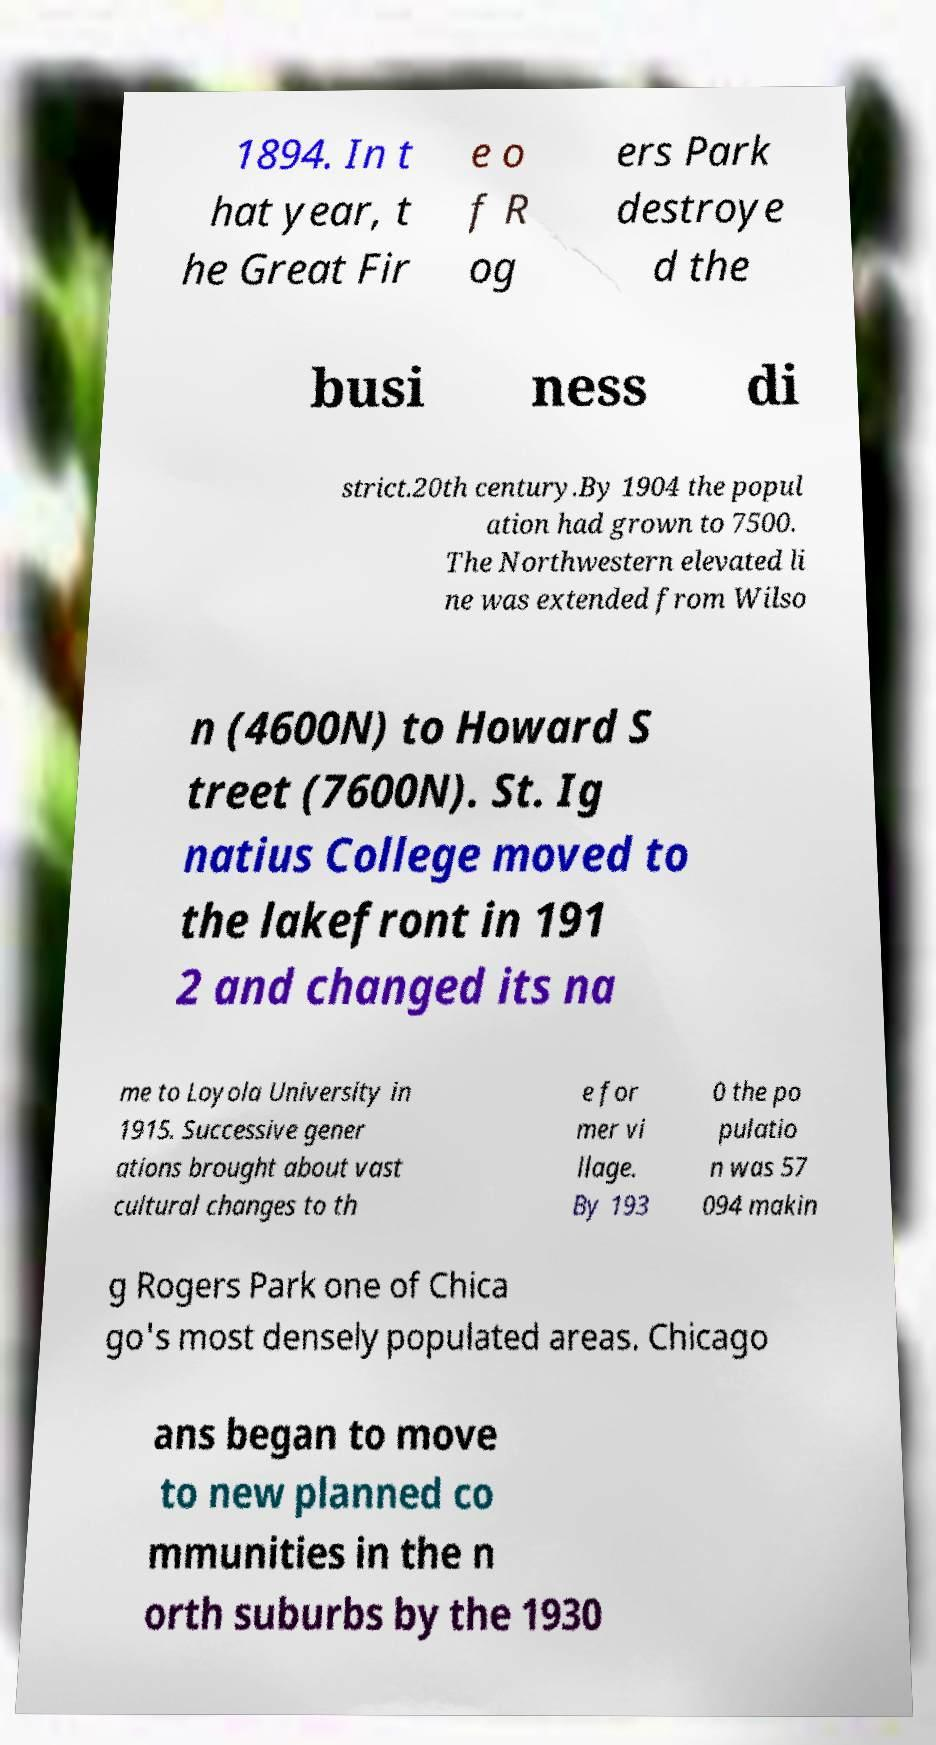Can you read and provide the text displayed in the image?This photo seems to have some interesting text. Can you extract and type it out for me? 1894. In t hat year, t he Great Fir e o f R og ers Park destroye d the busi ness di strict.20th century.By 1904 the popul ation had grown to 7500. The Northwestern elevated li ne was extended from Wilso n (4600N) to Howard S treet (7600N). St. Ig natius College moved to the lakefront in 191 2 and changed its na me to Loyola University in 1915. Successive gener ations brought about vast cultural changes to th e for mer vi llage. By 193 0 the po pulatio n was 57 094 makin g Rogers Park one of Chica go's most densely populated areas. Chicago ans began to move to new planned co mmunities in the n orth suburbs by the 1930 